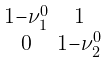<formula> <loc_0><loc_0><loc_500><loc_500>\begin{smallmatrix} 1 - \nu _ { 1 } ^ { 0 } & 1 \\ 0 & 1 - \nu _ { 2 } ^ { 0 } \\ \end{smallmatrix}</formula> 